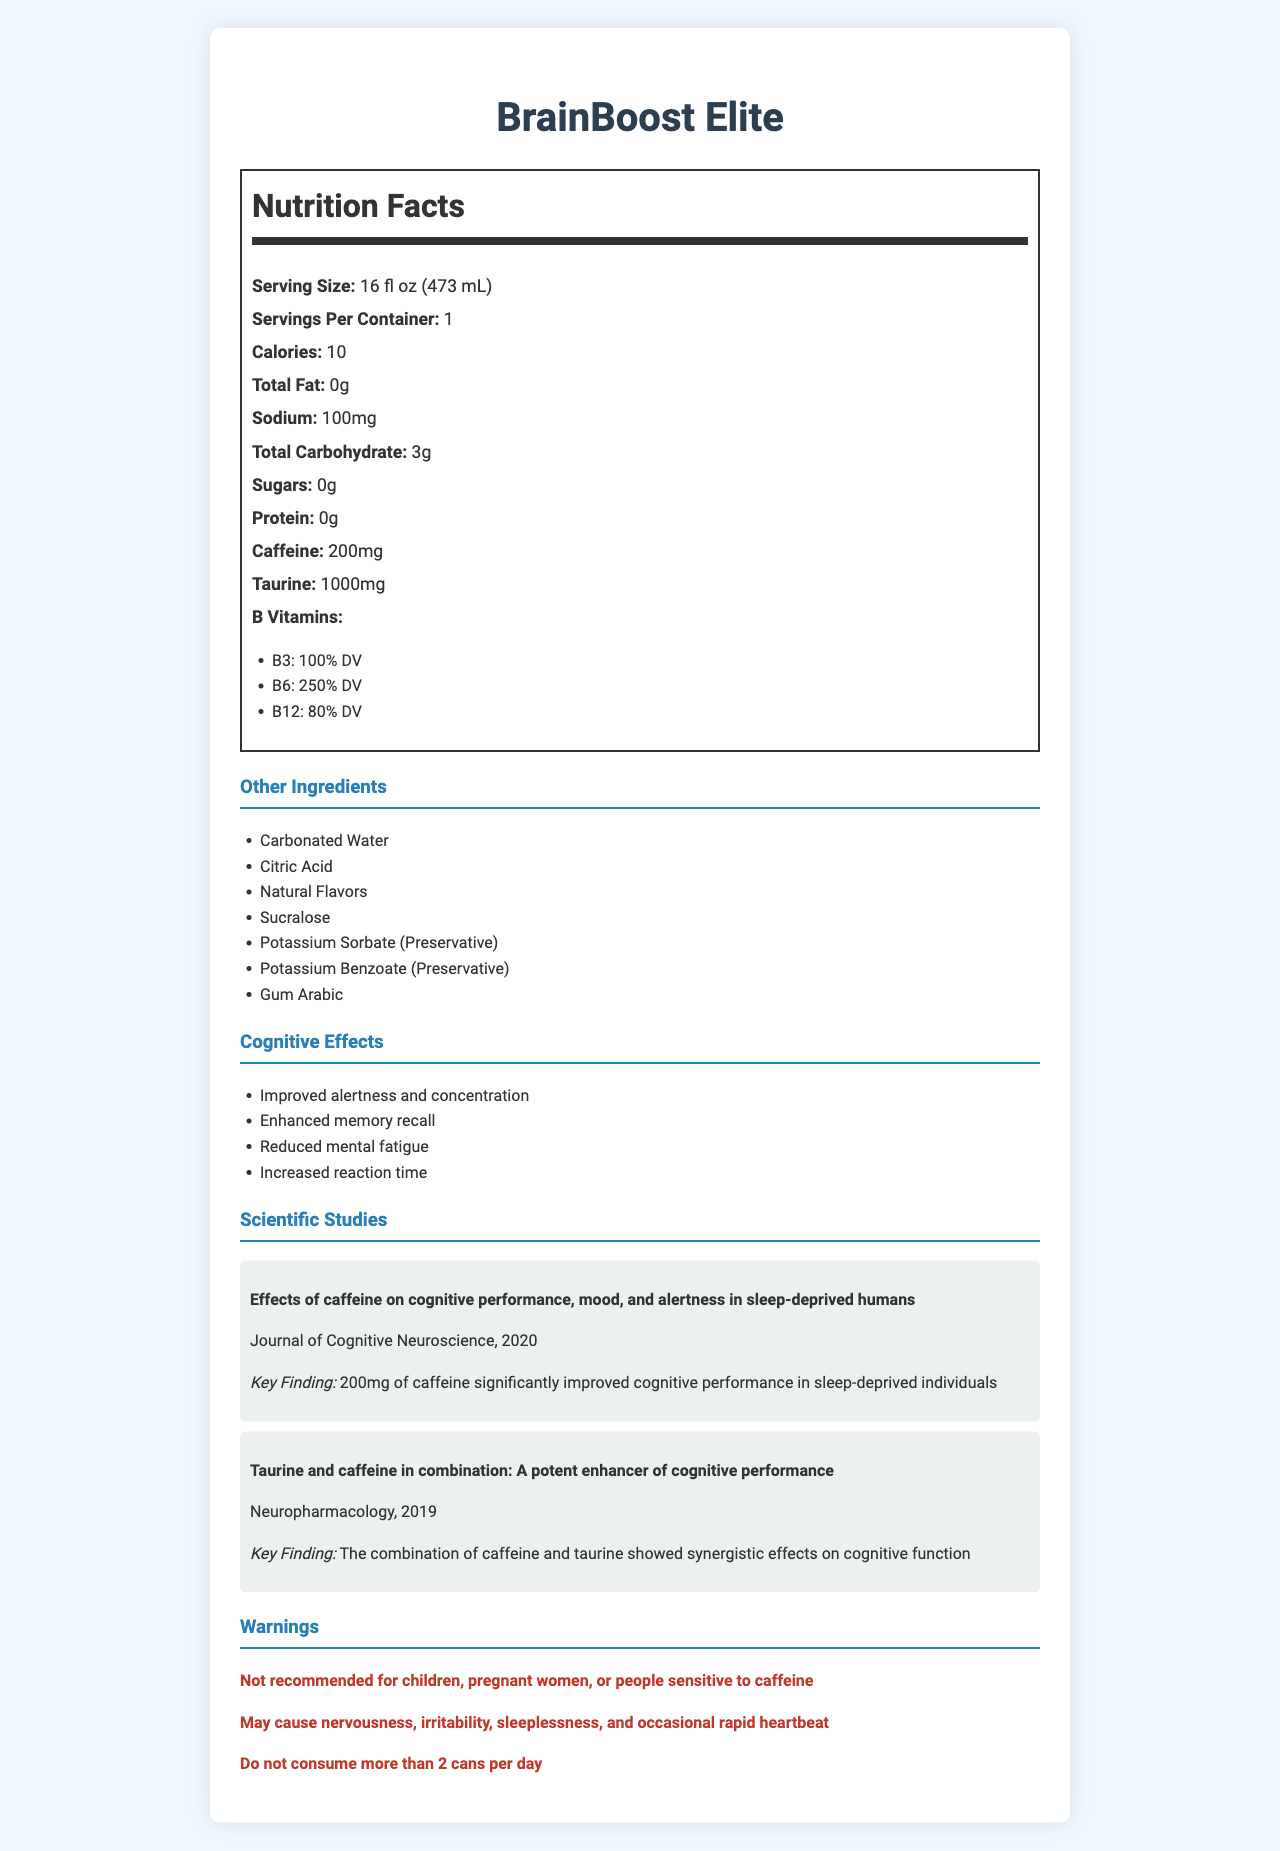What is the serving size of BrainBoost Elite? The serving size is clearly listed in the Nutrition Facts section of the document.
Answer: 16 fl oz (473 mL) How many calories are in one serving of BrainBoost Elite? The document lists the calorie content as 10 under the Nutrition Facts section.
Answer: 10 What is the amount of caffeine in BrainBoost Elite? The amount of caffeine is listed in the Nutrition Facts as 200mg.
Answer: 200mg What is the sodium content per serving? The Nutrition Facts section states the sodium content as 100mg.
Answer: 100mg List the B Vitamins and their percentage of daily value present in the energy drink. The Nutrition Facts section lists the B Vitamins with their respective daily values.
Answer: B3: 100% DV, B6: 250% DV, B12: 80% DV What are some cognitive effects mentioned for BrainBoost Elite? These effects are listed under the Cognitive Effects section.
Answer: Improved alertness and concentration, Enhanced memory recall, Reduced mental fatigue, Increased reaction time Which journal published the study titled "Effects of caffeine on cognitive performance, mood, and alertness in sleep-deprived humans"? A. Neuropharmacology B. Journal of Cognitive Neuroscience C. Cognitive Brain Research The document states this study was published in the "Journal of Cognitive Neuroscience".
Answer: B Which of the following is NOT a warning provided for BrainBoost Elite? A. Not recommended for children B. May cause rapid heartbeat C. Contains natural sweeteners The document lists warnings, and "Contains natural sweeteners" is not one of them.
Answer: C Is BrainBoost Elite recommended for children? Under the Warnings section, the document explicitly states that it is not recommended for children.
Answer: No Summarize the main idea of the document. The entire document provides detailed nutritional information, cognitive benefits, supported scientific studies, and necessary warnings about the energy drink BrainBoost Elite.
Answer: BrainBoost Elite is an energy drink designed to enhance cognitive functions. It contains 200mg of caffeine, 1000mg of taurine, and high levels of B vitamins, all contributing to improved alertness, concentration, memory recall, and reduced mental fatigue. Notable studies support its efficacy, but warnings suggest caution for specific populations. What is the main preservative used in BrainBoost Elite? The document lists "Potassium Sorbate (Preservative)" and "Potassium Benzoate (Preservative)" under other ingredients.
Answer: Potassium Sorbate and Potassium Benzoate How much protein is present per serving? The Nutrition Facts section indicates that there is 0g of protein per serving.
Answer: 0g I drank two cans of BrainBoost Elite today, is that safe? The Warnings section advises not to consume more than 2 cans per day, implying it is the maximum limit and not recommended.
Answer: No How does the combination of caffeine and taurine enhance cognitive function, according to the studies? The document highlights a study from "Neuropharmacology" which found that the combination of caffeine and taurine enhanced cognitive performance.
Answer: The combination of caffeine and taurine showed synergistic effects on cognitive function What is the potential long-term impact of regular consumption of energy drinks on brain plasticity? The document does not provide specific data or conclusions on the long-term impact of energy drink consumption on brain plasticity.
Answer: Not enough information 